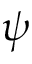Convert formula to latex. <formula><loc_0><loc_0><loc_500><loc_500>\psi</formula> 